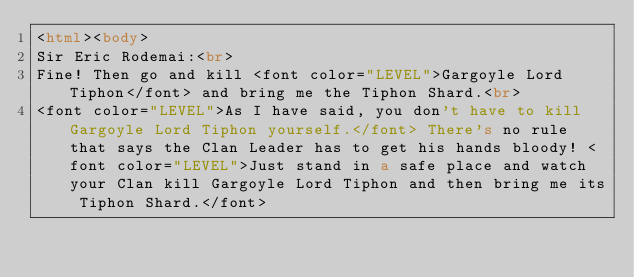<code> <loc_0><loc_0><loc_500><loc_500><_HTML_><html><body>
Sir Eric Rodemai:<br>
Fine! Then go and kill <font color="LEVEL">Gargoyle Lord Tiphon</font> and bring me the Tiphon Shard.<br>
<font color="LEVEL">As I have said, you don't have to kill Gargoyle Lord Tiphon yourself.</font> There's no rule that says the Clan Leader has to get his hands bloody! <font color="LEVEL">Just stand in a safe place and watch your Clan kill Gargoyle Lord Tiphon and then bring me its Tiphon Shard.</font></code> 